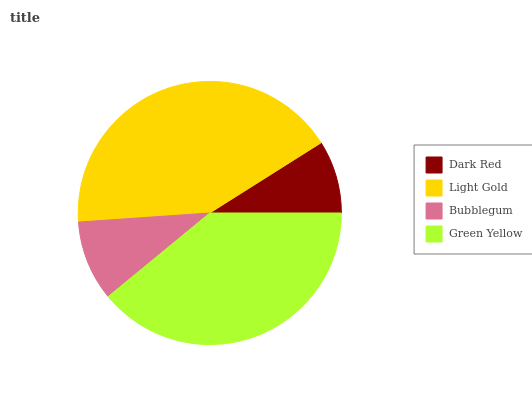Is Dark Red the minimum?
Answer yes or no. Yes. Is Light Gold the maximum?
Answer yes or no. Yes. Is Bubblegum the minimum?
Answer yes or no. No. Is Bubblegum the maximum?
Answer yes or no. No. Is Light Gold greater than Bubblegum?
Answer yes or no. Yes. Is Bubblegum less than Light Gold?
Answer yes or no. Yes. Is Bubblegum greater than Light Gold?
Answer yes or no. No. Is Light Gold less than Bubblegum?
Answer yes or no. No. Is Green Yellow the high median?
Answer yes or no. Yes. Is Bubblegum the low median?
Answer yes or no. Yes. Is Light Gold the high median?
Answer yes or no. No. Is Dark Red the low median?
Answer yes or no. No. 